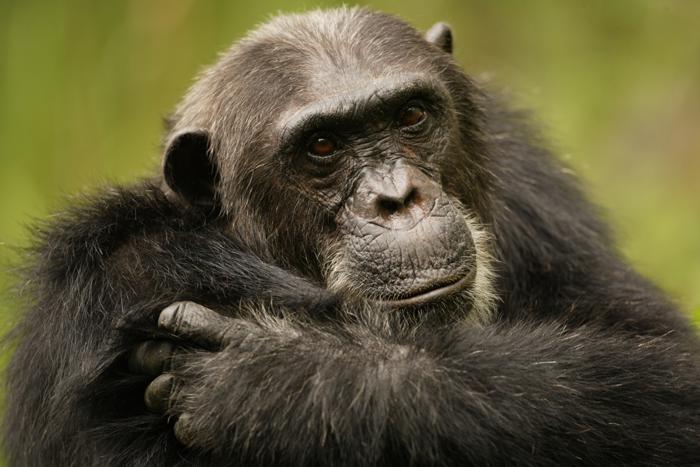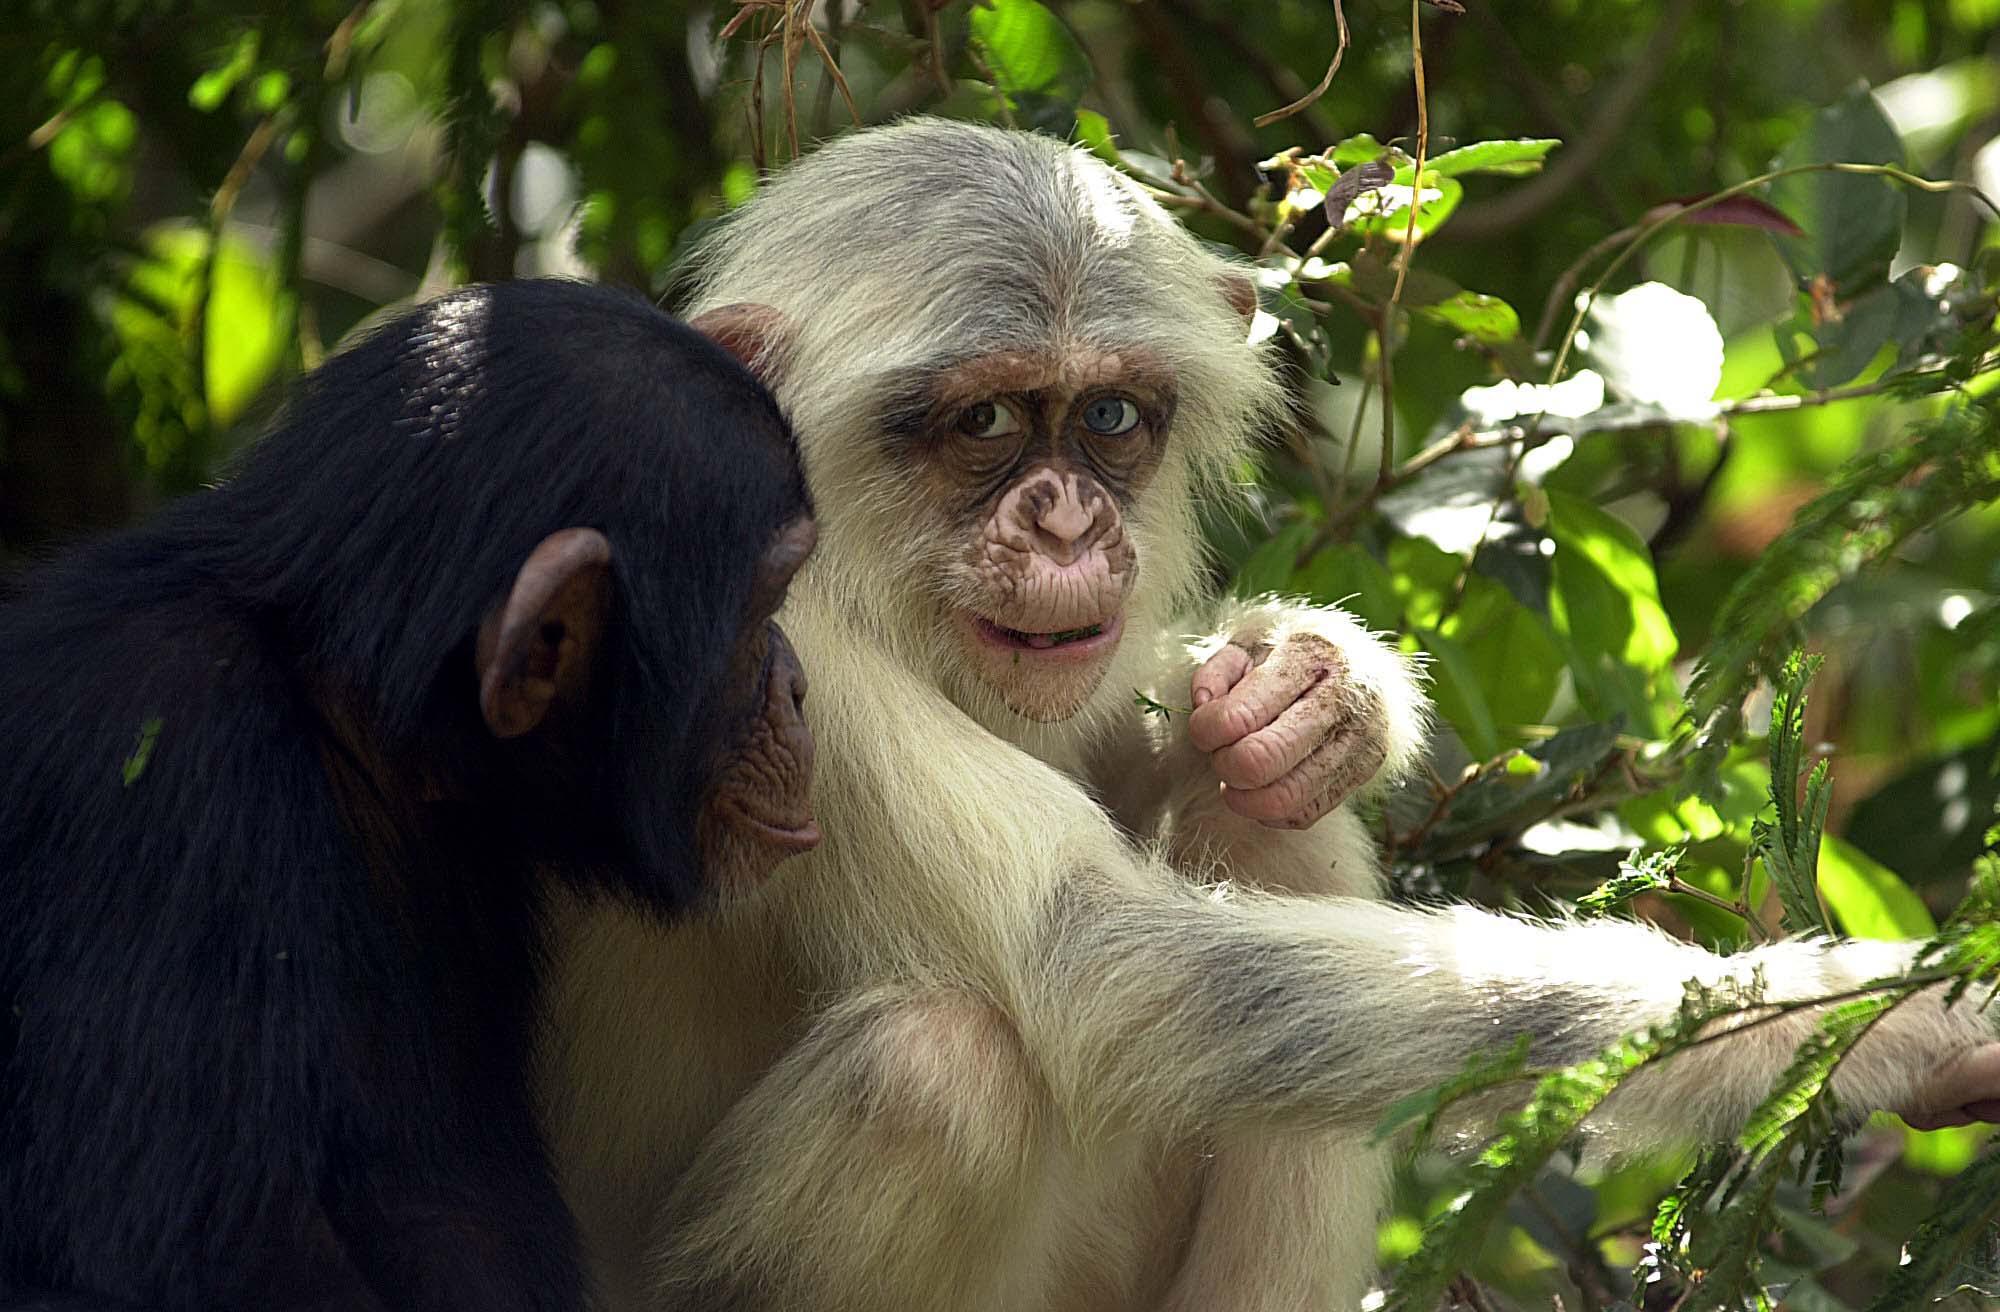The first image is the image on the left, the second image is the image on the right. Examine the images to the left and right. Is the description "there is exactly one animal in the image on the left" accurate? Answer yes or no. Yes. The first image is the image on the left, the second image is the image on the right. Given the left and right images, does the statement "An image shows one adult chimp next to a baby chimp, with both faces visible." hold true? Answer yes or no. No. 